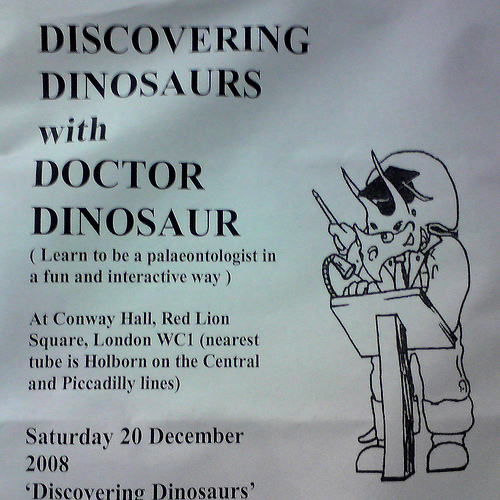<image>
Is there a dinosaur on the podium? No. The dinosaur is not positioned on the podium. They may be near each other, but the dinosaur is not supported by or resting on top of the podium. Is the dinosaur behind the podium? Yes. From this viewpoint, the dinosaur is positioned behind the podium, with the podium partially or fully occluding the dinosaur. Is there a cartoon behind the text? No. The cartoon is not behind the text. From this viewpoint, the cartoon appears to be positioned elsewhere in the scene. 